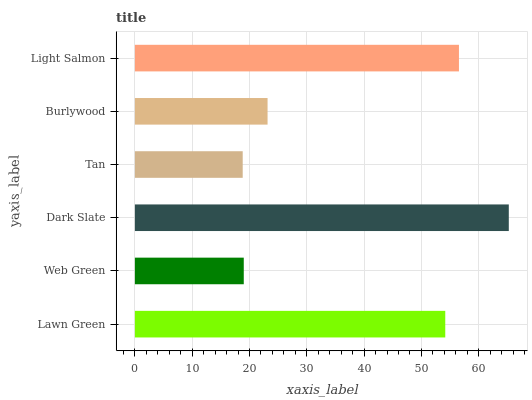Is Tan the minimum?
Answer yes or no. Yes. Is Dark Slate the maximum?
Answer yes or no. Yes. Is Web Green the minimum?
Answer yes or no. No. Is Web Green the maximum?
Answer yes or no. No. Is Lawn Green greater than Web Green?
Answer yes or no. Yes. Is Web Green less than Lawn Green?
Answer yes or no. Yes. Is Web Green greater than Lawn Green?
Answer yes or no. No. Is Lawn Green less than Web Green?
Answer yes or no. No. Is Lawn Green the high median?
Answer yes or no. Yes. Is Burlywood the low median?
Answer yes or no. Yes. Is Burlywood the high median?
Answer yes or no. No. Is Web Green the low median?
Answer yes or no. No. 